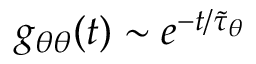Convert formula to latex. <formula><loc_0><loc_0><loc_500><loc_500>g _ { \theta \theta } ( t ) \sim e ^ { - t / \tilde { \tau } _ { \theta } }</formula> 